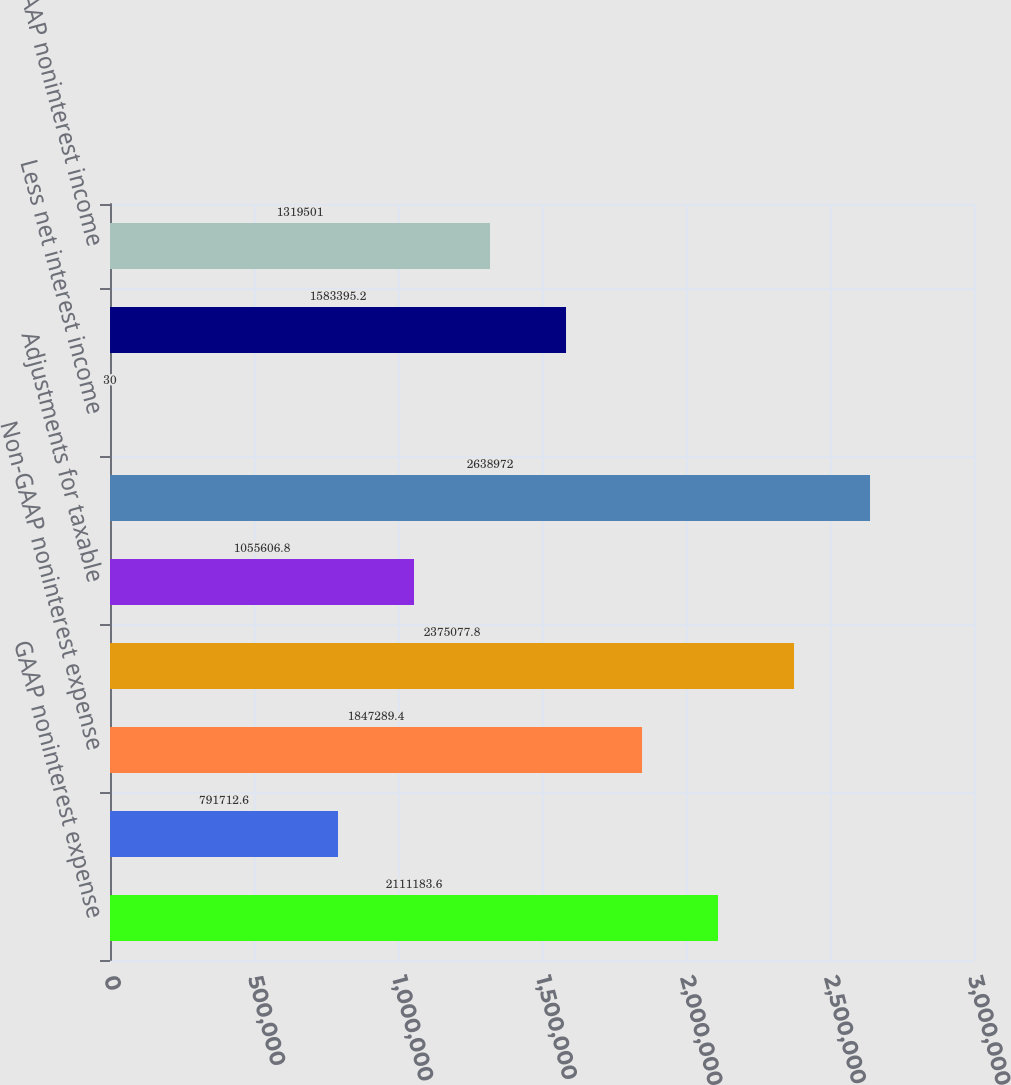Convert chart. <chart><loc_0><loc_0><loc_500><loc_500><bar_chart><fcel>GAAP noninterest expense<fcel>Less expense attributable to<fcel>Non-GAAP noninterest expense<fcel>GAAP net interest income<fcel>Adjustments for taxable<fcel>Non-GAAP taxable equivalent<fcel>Less net interest income<fcel>GAAP noninterest income<fcel>Non-GAAP noninterest income<nl><fcel>2.11118e+06<fcel>791713<fcel>1.84729e+06<fcel>2.37508e+06<fcel>1.05561e+06<fcel>2.63897e+06<fcel>30<fcel>1.5834e+06<fcel>1.3195e+06<nl></chart> 